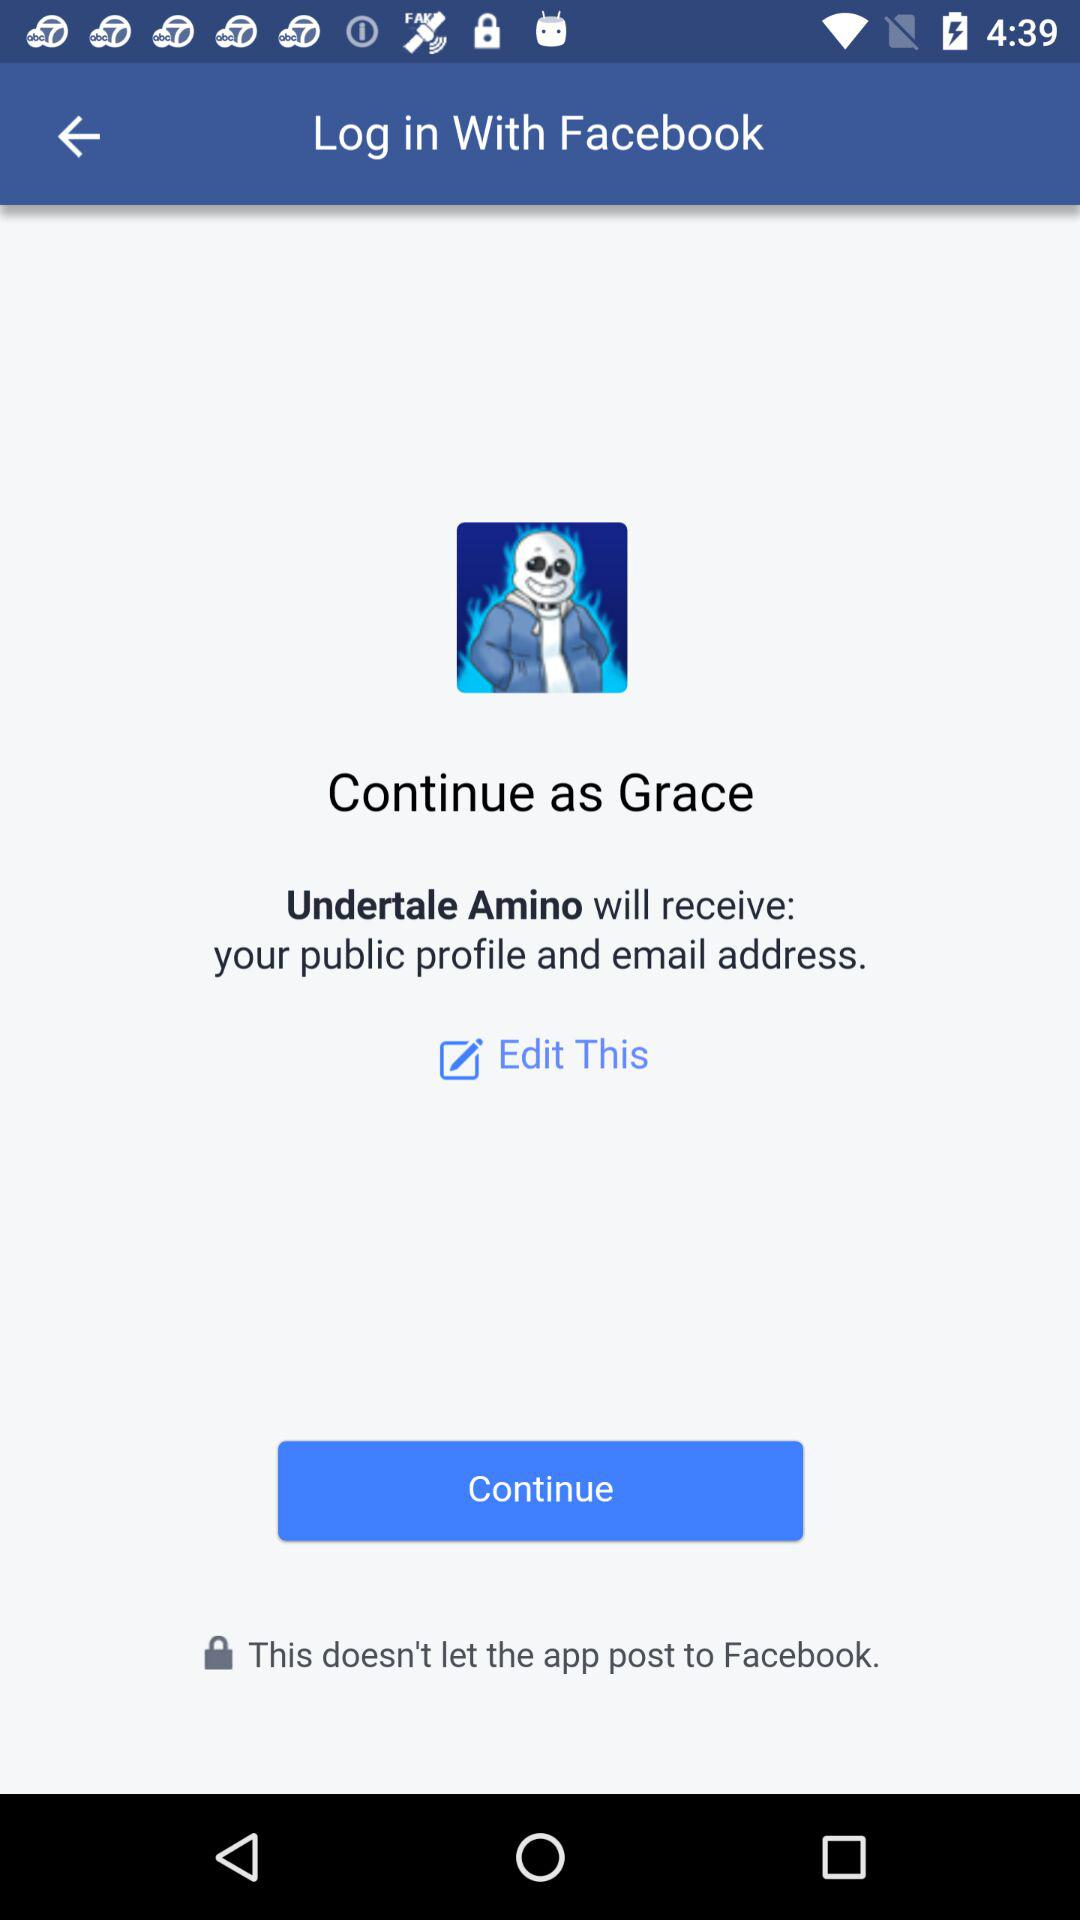Who will receive my public profile and email address? Your public profile and email address will be received by "Undertale Amino". 